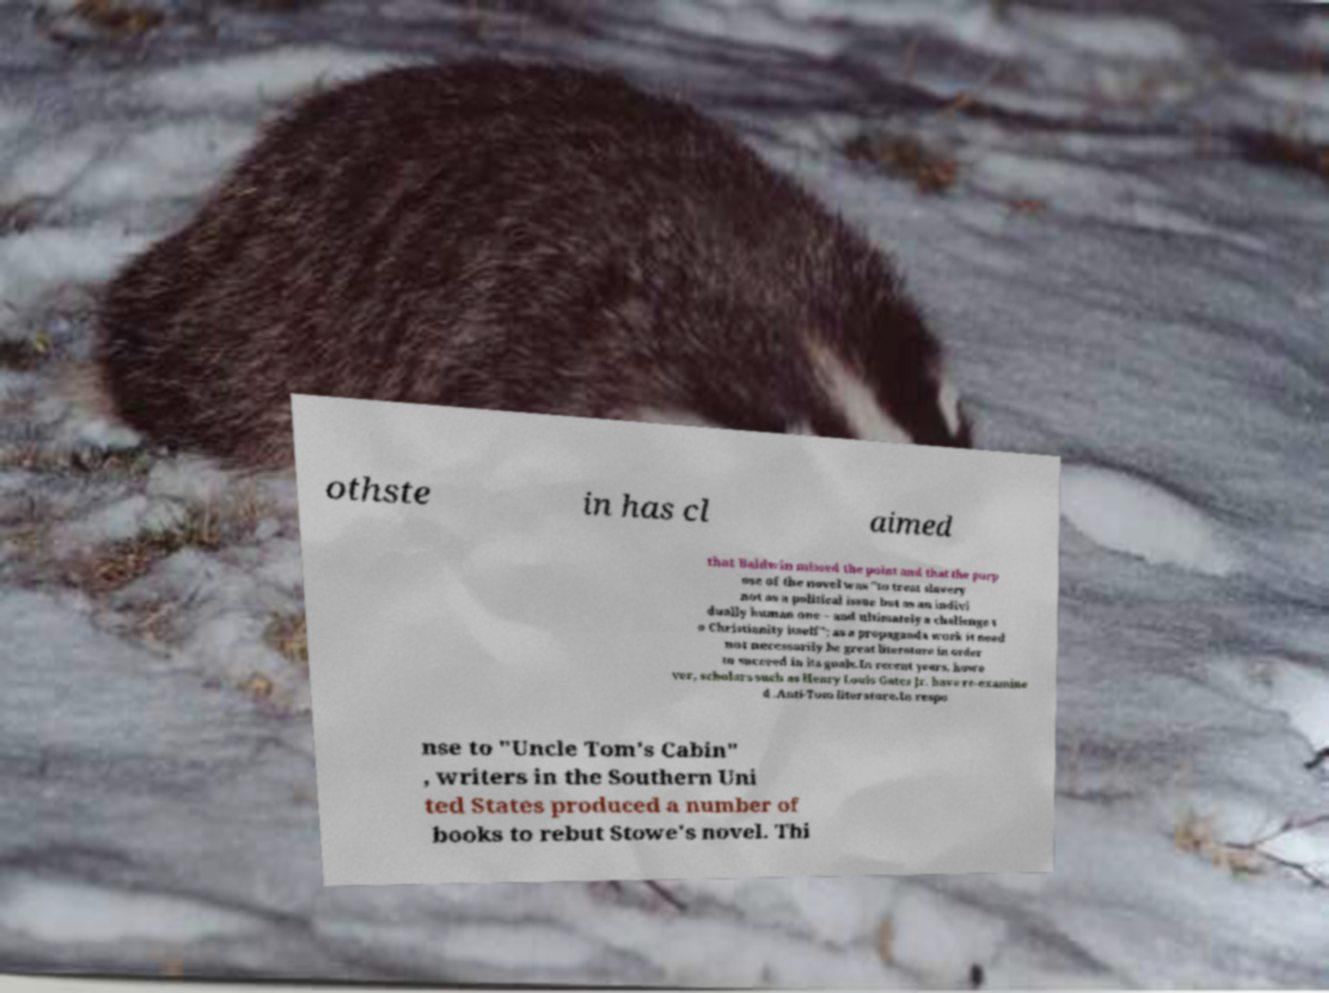What messages or text are displayed in this image? I need them in a readable, typed format. othste in has cl aimed that Baldwin missed the point and that the purp ose of the novel was "to treat slavery not as a political issue but as an indivi dually human one – and ultimately a challenge t o Christianity itself"; as a propaganda work it need not necessarily be great literature in order to succeed in its goals.In recent years, howe ver, scholars such as Henry Louis Gates Jr. have re-examine d .Anti-Tom literature.In respo nse to "Uncle Tom's Cabin" , writers in the Southern Uni ted States produced a number of books to rebut Stowe's novel. Thi 